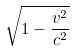<formula> <loc_0><loc_0><loc_500><loc_500>\sqrt { 1 - \frac { v ^ { 2 } } { c ^ { 2 } } }</formula> 